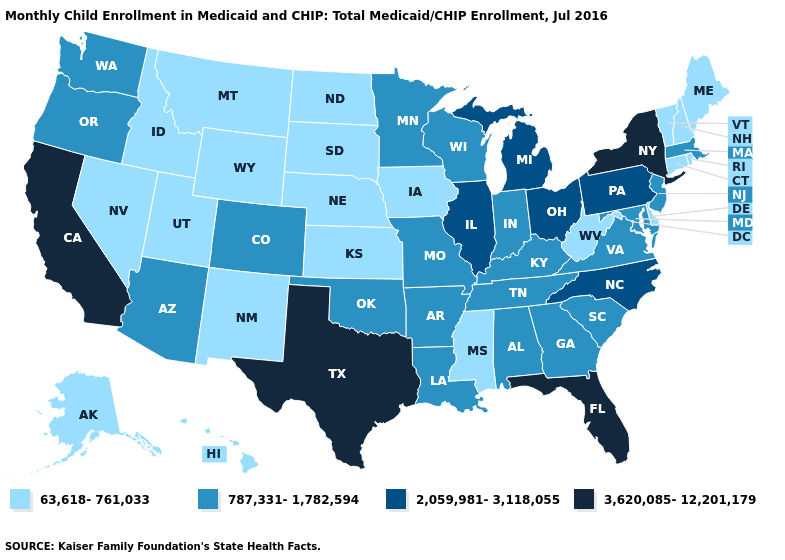Name the states that have a value in the range 3,620,085-12,201,179?
Be succinct. California, Florida, New York, Texas. What is the value of Idaho?
Quick response, please. 63,618-761,033. Which states hav the highest value in the West?
Short answer required. California. Name the states that have a value in the range 63,618-761,033?
Be succinct. Alaska, Connecticut, Delaware, Hawaii, Idaho, Iowa, Kansas, Maine, Mississippi, Montana, Nebraska, Nevada, New Hampshire, New Mexico, North Dakota, Rhode Island, South Dakota, Utah, Vermont, West Virginia, Wyoming. Name the states that have a value in the range 3,620,085-12,201,179?
Short answer required. California, Florida, New York, Texas. Name the states that have a value in the range 3,620,085-12,201,179?
Quick response, please. California, Florida, New York, Texas. Does Kentucky have the same value as New Jersey?
Concise answer only. Yes. What is the value of South Dakota?
Quick response, please. 63,618-761,033. What is the value of New Jersey?
Answer briefly. 787,331-1,782,594. What is the lowest value in states that border Minnesota?
Short answer required. 63,618-761,033. Is the legend a continuous bar?
Keep it brief. No. What is the value of Pennsylvania?
Answer briefly. 2,059,981-3,118,055. What is the lowest value in states that border Florida?
Quick response, please. 787,331-1,782,594. Name the states that have a value in the range 63,618-761,033?
Answer briefly. Alaska, Connecticut, Delaware, Hawaii, Idaho, Iowa, Kansas, Maine, Mississippi, Montana, Nebraska, Nevada, New Hampshire, New Mexico, North Dakota, Rhode Island, South Dakota, Utah, Vermont, West Virginia, Wyoming. Name the states that have a value in the range 2,059,981-3,118,055?
Be succinct. Illinois, Michigan, North Carolina, Ohio, Pennsylvania. 